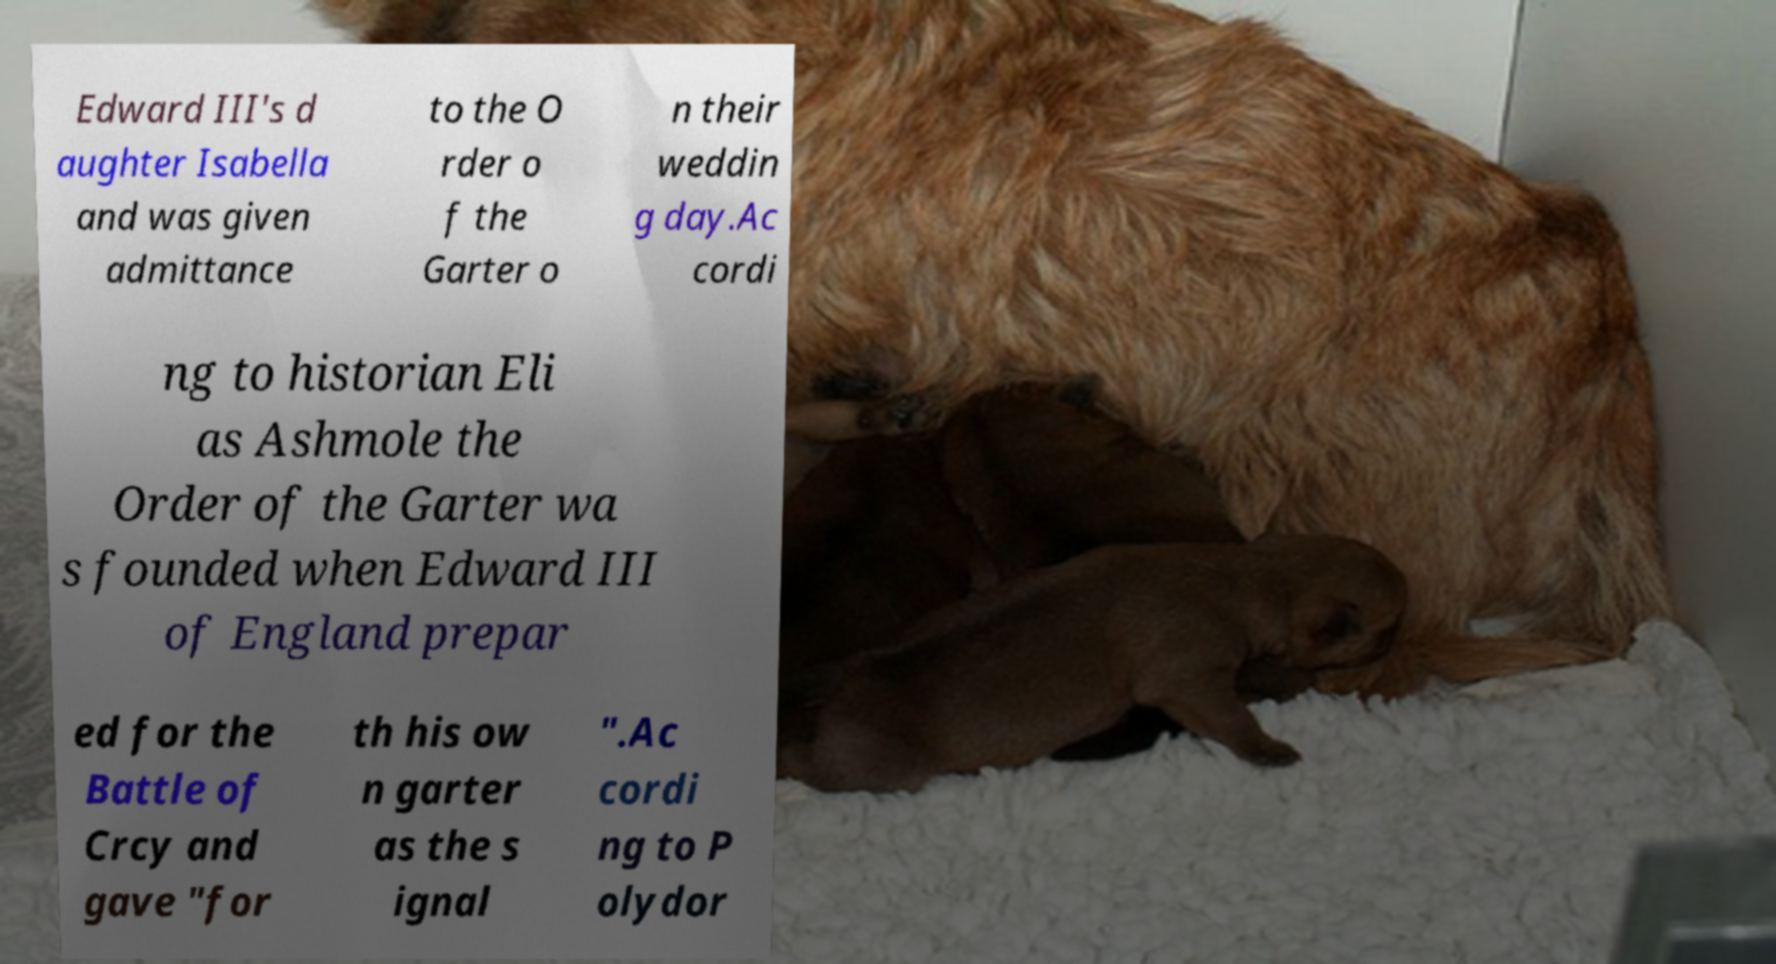I need the written content from this picture converted into text. Can you do that? Edward III's d aughter Isabella and was given admittance to the O rder o f the Garter o n their weddin g day.Ac cordi ng to historian Eli as Ashmole the Order of the Garter wa s founded when Edward III of England prepar ed for the Battle of Crcy and gave "for th his ow n garter as the s ignal ".Ac cordi ng to P olydor 